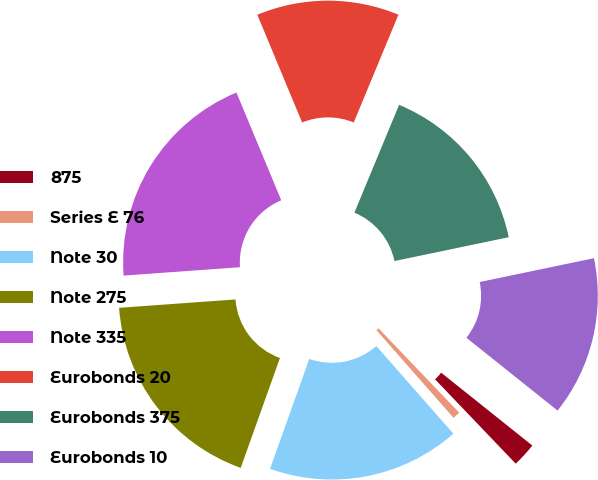Convert chart to OTSL. <chart><loc_0><loc_0><loc_500><loc_500><pie_chart><fcel>875<fcel>Series E 76<fcel>Note 30<fcel>Note 275<fcel>Note 335<fcel>Eurobonds 20<fcel>Eurobonds 375<fcel>Eurobonds 10<nl><fcel>2.13%<fcel>0.66%<fcel>16.94%<fcel>18.4%<fcel>19.87%<fcel>12.53%<fcel>15.47%<fcel>14.0%<nl></chart> 